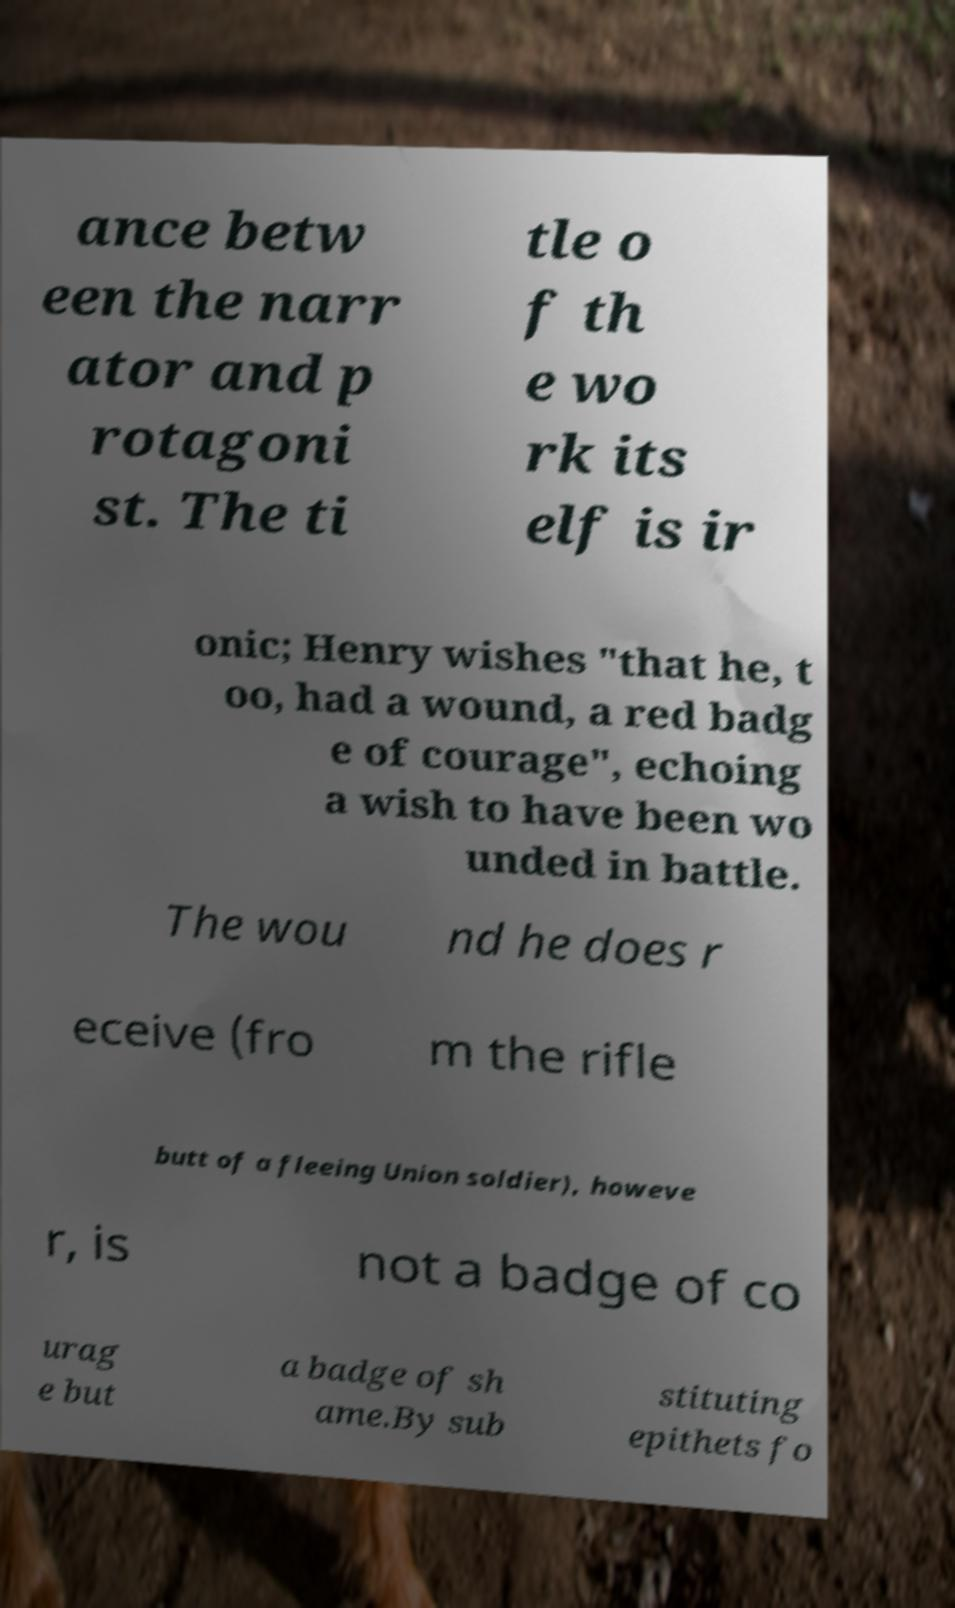Can you read and provide the text displayed in the image?This photo seems to have some interesting text. Can you extract and type it out for me? ance betw een the narr ator and p rotagoni st. The ti tle o f th e wo rk its elf is ir onic; Henry wishes "that he, t oo, had a wound, a red badg e of courage", echoing a wish to have been wo unded in battle. The wou nd he does r eceive (fro m the rifle butt of a fleeing Union soldier), howeve r, is not a badge of co urag e but a badge of sh ame.By sub stituting epithets fo 